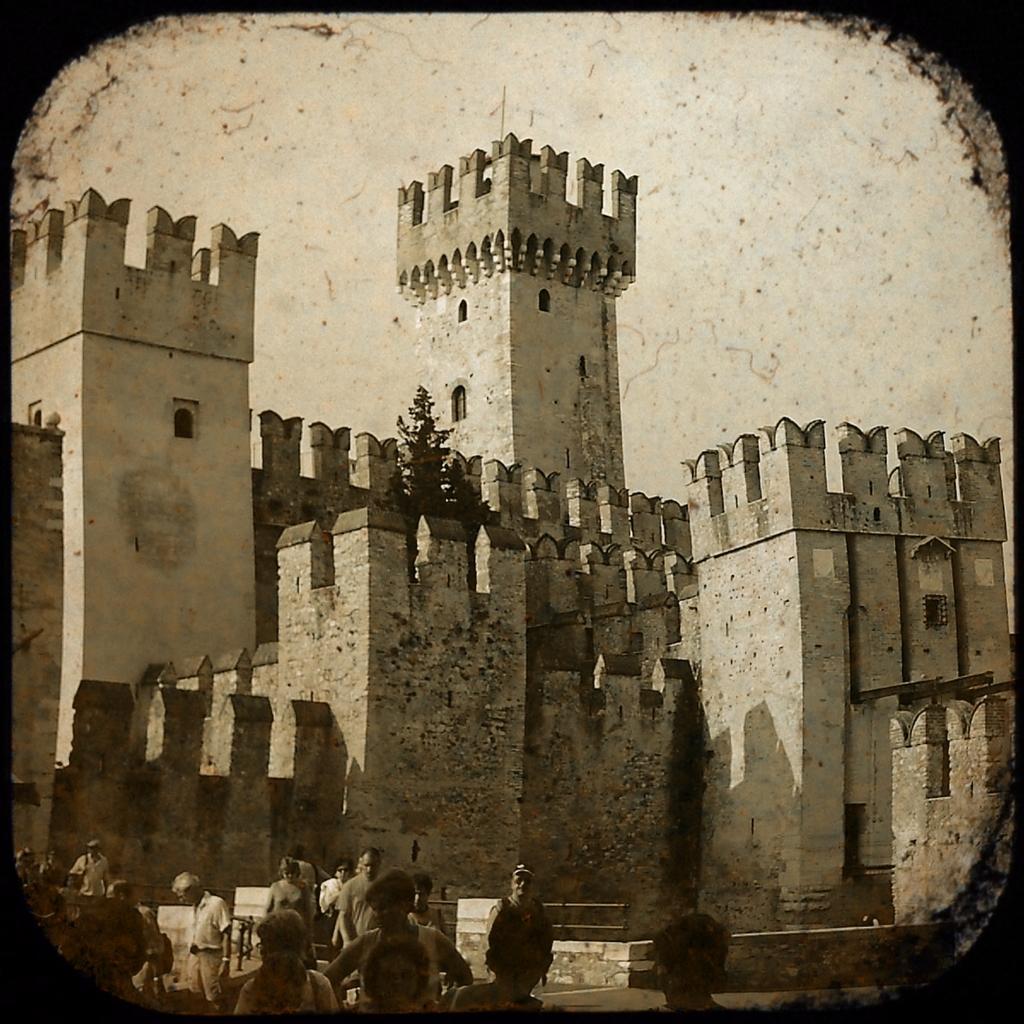Can you describe this image briefly? In the center of the image there is a castle. At the bottom there are people. In the background there is sky. 